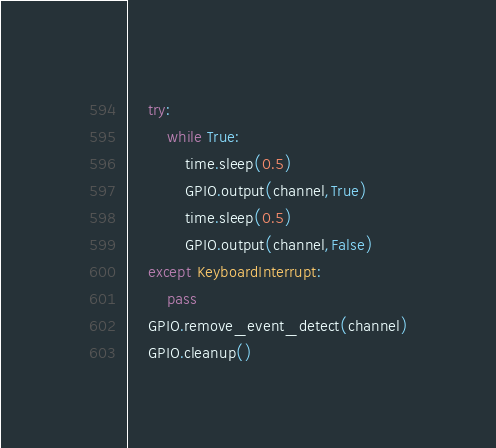Convert code to text. <code><loc_0><loc_0><loc_500><loc_500><_Python_>	try:
		while True:
			time.sleep(0.5)
			GPIO.output(channel,True)
			time.sleep(0.5)
			GPIO.output(channel,False)
	except KeyboardInterrupt:
		pass
	GPIO.remove_event_detect(channel)
	GPIO.cleanup()
</code> 